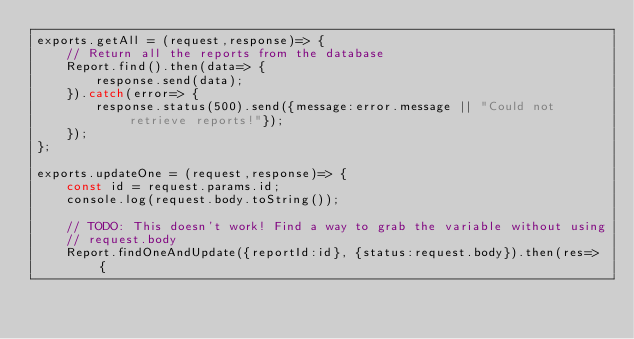Convert code to text. <code><loc_0><loc_0><loc_500><loc_500><_JavaScript_>exports.getAll = (request,response)=> {
    // Return all the reports from the database
    Report.find().then(data=> {
        response.send(data);
    }).catch(error=> {
        response.status(500).send({message:error.message || "Could not retrieve reports!"});
    });
};

exports.updateOne = (request,response)=> {
    const id = request.params.id;
    console.log(request.body.toString());

    // TODO: This doesn't work! Find a way to grab the variable without using
    // request.body
    Report.findOneAndUpdate({reportId:id}, {status:request.body}).then(res=> {</code> 